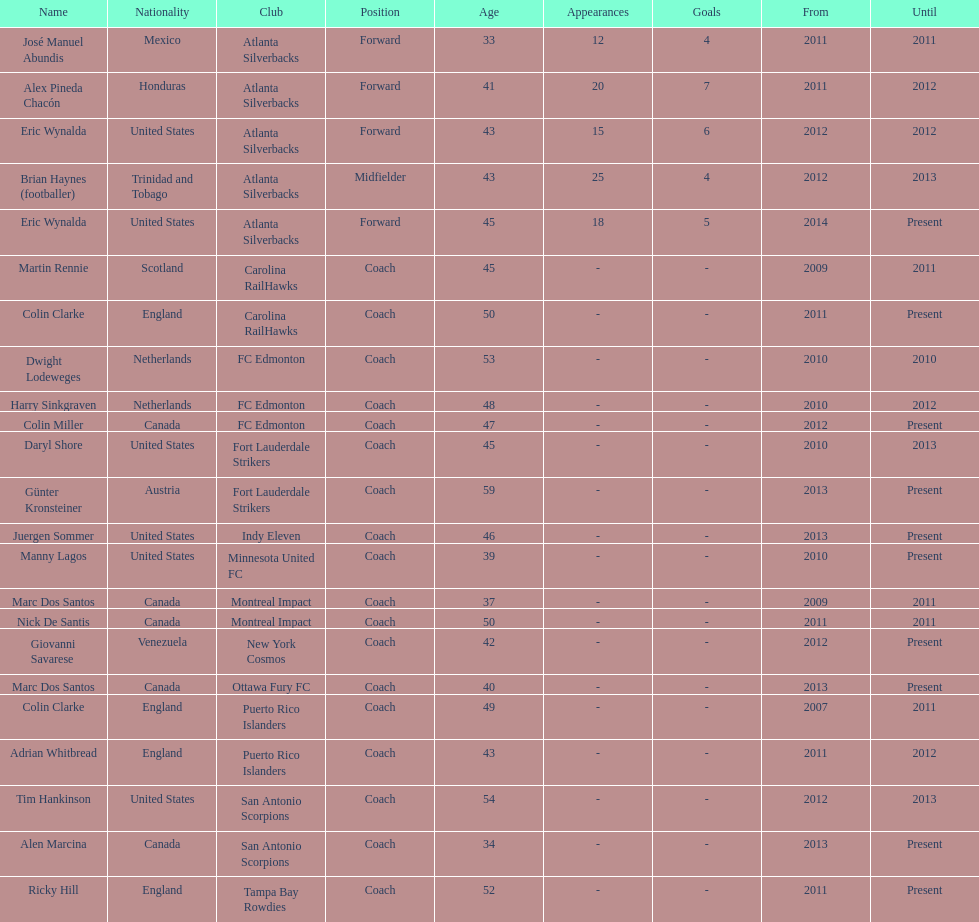Who was the coach of fc edmonton before miller? Harry Sinkgraven. 